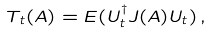<formula> <loc_0><loc_0><loc_500><loc_500>T _ { t } ( A ) = E ( U _ { t } ^ { \dagger } J ( A ) U _ { t } ) \, ,</formula> 